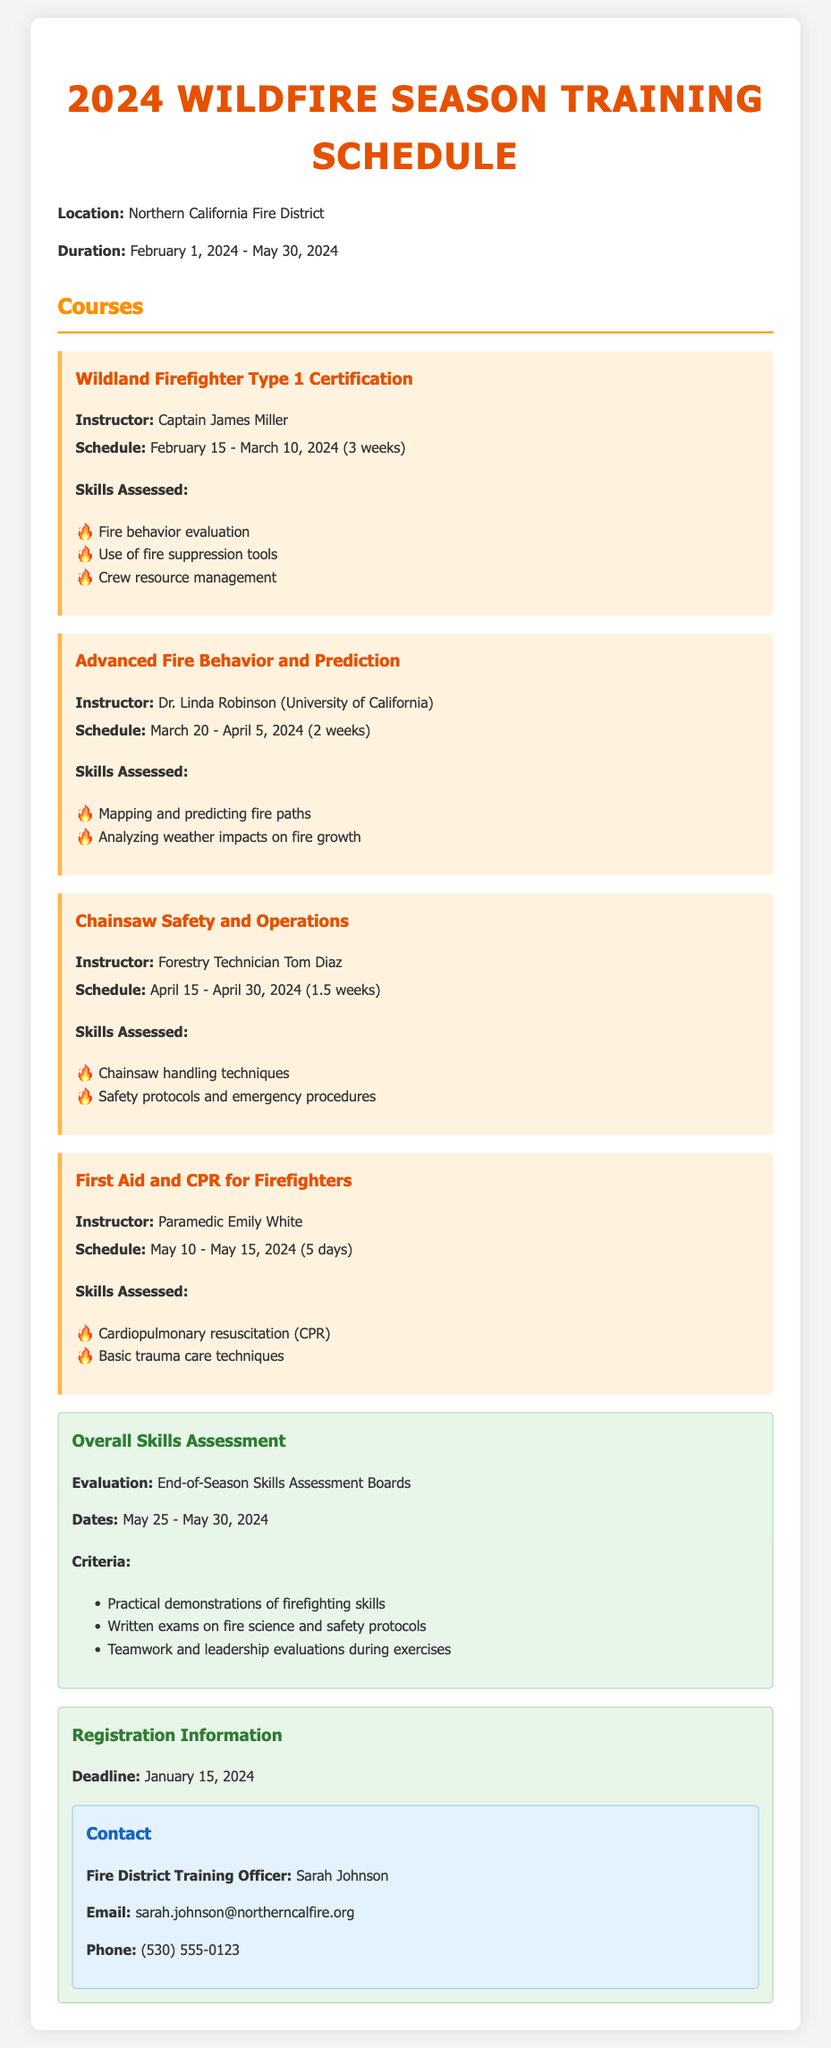What is the training location? The training location is specified in the document as "Northern California Fire District."
Answer: Northern California Fire District What is the duration of the training? The duration of the training is mentioned as "February 1, 2024 - May 30, 2024."
Answer: February 1, 2024 - May 30, 2024 Who is the instructor for the Chainsaw Safety and Operations course? The document lists "Forestry Technician Tom Diaz" as the instructor for this course.
Answer: Forestry Technician Tom Diaz When does the Advanced Fire Behavior and Prediction course start? The starting date for the course is provided as "March 20, 2024."
Answer: March 20, 2024 What skills are assessed in the Wildland Firefighter Type 1 Certification course? The skills assessed include "Fire behavior evaluation, Use of fire suppression tools, Crew resource management."
Answer: Fire behavior evaluation, Use of fire suppression tools, Crew resource management What is the deadline for registration? The document states the registration deadline as "January 15, 2024."
Answer: January 15, 2024 What kind of assessments will be conducted at the end of the season? The document specifies "End-of-Season Skills Assessment Boards" for evaluation.
Answer: End-of-Season Skills Assessment Boards What is the total duration of the First Aid and CPR for Firefighters course? The duration for this course is listed as "5 days."
Answer: 5 days Who can be contacted for more information regarding training? The contact person mentioned in the document is "Sarah Johnson."
Answer: Sarah Johnson 